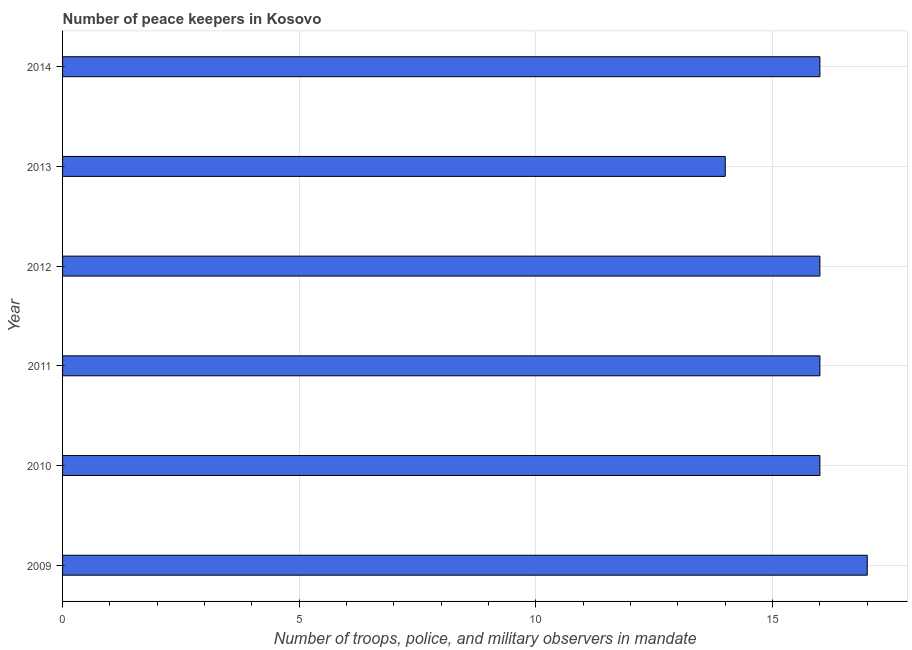What is the title of the graph?
Make the answer very short. Number of peace keepers in Kosovo. What is the label or title of the X-axis?
Keep it short and to the point. Number of troops, police, and military observers in mandate. What is the number of peace keepers in 2014?
Offer a very short reply. 16. Across all years, what is the maximum number of peace keepers?
Ensure brevity in your answer.  17. In which year was the number of peace keepers minimum?
Your answer should be very brief. 2013. What is the sum of the number of peace keepers?
Give a very brief answer. 95. What is the difference between the number of peace keepers in 2012 and 2014?
Provide a succinct answer. 0. What is the ratio of the number of peace keepers in 2012 to that in 2014?
Provide a succinct answer. 1. What is the difference between the highest and the second highest number of peace keepers?
Keep it short and to the point. 1. Is the sum of the number of peace keepers in 2012 and 2013 greater than the maximum number of peace keepers across all years?
Provide a short and direct response. Yes. What is the difference between the highest and the lowest number of peace keepers?
Your response must be concise. 3. How many bars are there?
Make the answer very short. 6. Are all the bars in the graph horizontal?
Your response must be concise. Yes. How many years are there in the graph?
Your response must be concise. 6. What is the difference between two consecutive major ticks on the X-axis?
Offer a terse response. 5. Are the values on the major ticks of X-axis written in scientific E-notation?
Your response must be concise. No. What is the Number of troops, police, and military observers in mandate in 2013?
Keep it short and to the point. 14. What is the difference between the Number of troops, police, and military observers in mandate in 2009 and 2010?
Give a very brief answer. 1. What is the difference between the Number of troops, police, and military observers in mandate in 2009 and 2013?
Provide a short and direct response. 3. What is the difference between the Number of troops, police, and military observers in mandate in 2009 and 2014?
Offer a very short reply. 1. What is the difference between the Number of troops, police, and military observers in mandate in 2010 and 2012?
Provide a short and direct response. 0. What is the difference between the Number of troops, police, and military observers in mandate in 2010 and 2013?
Offer a very short reply. 2. What is the difference between the Number of troops, police, and military observers in mandate in 2010 and 2014?
Provide a short and direct response. 0. What is the difference between the Number of troops, police, and military observers in mandate in 2011 and 2012?
Offer a very short reply. 0. What is the difference between the Number of troops, police, and military observers in mandate in 2011 and 2013?
Your answer should be very brief. 2. What is the difference between the Number of troops, police, and military observers in mandate in 2011 and 2014?
Offer a terse response. 0. What is the difference between the Number of troops, police, and military observers in mandate in 2012 and 2013?
Offer a very short reply. 2. What is the difference between the Number of troops, police, and military observers in mandate in 2012 and 2014?
Make the answer very short. 0. What is the ratio of the Number of troops, police, and military observers in mandate in 2009 to that in 2010?
Your answer should be compact. 1.06. What is the ratio of the Number of troops, police, and military observers in mandate in 2009 to that in 2011?
Provide a short and direct response. 1.06. What is the ratio of the Number of troops, police, and military observers in mandate in 2009 to that in 2012?
Keep it short and to the point. 1.06. What is the ratio of the Number of troops, police, and military observers in mandate in 2009 to that in 2013?
Your answer should be very brief. 1.21. What is the ratio of the Number of troops, police, and military observers in mandate in 2009 to that in 2014?
Your answer should be very brief. 1.06. What is the ratio of the Number of troops, police, and military observers in mandate in 2010 to that in 2012?
Offer a terse response. 1. What is the ratio of the Number of troops, police, and military observers in mandate in 2010 to that in 2013?
Give a very brief answer. 1.14. What is the ratio of the Number of troops, police, and military observers in mandate in 2010 to that in 2014?
Give a very brief answer. 1. What is the ratio of the Number of troops, police, and military observers in mandate in 2011 to that in 2012?
Ensure brevity in your answer.  1. What is the ratio of the Number of troops, police, and military observers in mandate in 2011 to that in 2013?
Provide a succinct answer. 1.14. What is the ratio of the Number of troops, police, and military observers in mandate in 2012 to that in 2013?
Your response must be concise. 1.14. What is the ratio of the Number of troops, police, and military observers in mandate in 2013 to that in 2014?
Offer a very short reply. 0.88. 